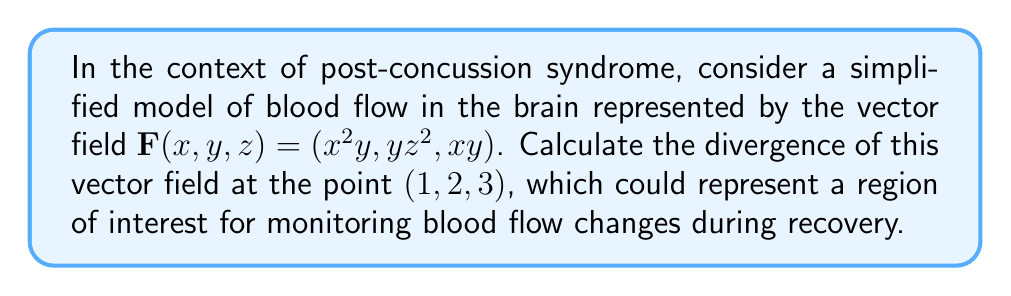Can you answer this question? To calculate the divergence of the vector field $\mathbf{F}(x,y,z) = (x^2y, yz^2, xy)$ at the point $(1,2,3)$, we follow these steps:

1) The divergence of a vector field $\mathbf{F}(x,y,z) = (F_1, F_2, F_3)$ is given by:

   $$\text{div}\mathbf{F} = \nabla \cdot \mathbf{F} = \frac{\partial F_1}{\partial x} + \frac{\partial F_2}{\partial y} + \frac{\partial F_3}{\partial z}$$

2) For our vector field:
   $F_1 = x^2y$
   $F_2 = yz^2$
   $F_3 = xy$

3) Calculate the partial derivatives:
   $\frac{\partial F_1}{\partial x} = 2xy$
   $\frac{\partial F_2}{\partial y} = z^2$
   $\frac{\partial F_3}{\partial z} = 0$

4) Sum the partial derivatives:
   $$\text{div}\mathbf{F} = 2xy + z^2 + 0 = 2xy + z^2$$

5) Evaluate at the point $(1,2,3)$:
   $$\text{div}\mathbf{F}(1,2,3) = 2(1)(2) + 3^2 = 4 + 9 = 13$$

This positive divergence indicates that there is a net outflow of blood from this point, which could be relevant in monitoring blood flow patterns during post-concussion recovery.
Answer: 13 